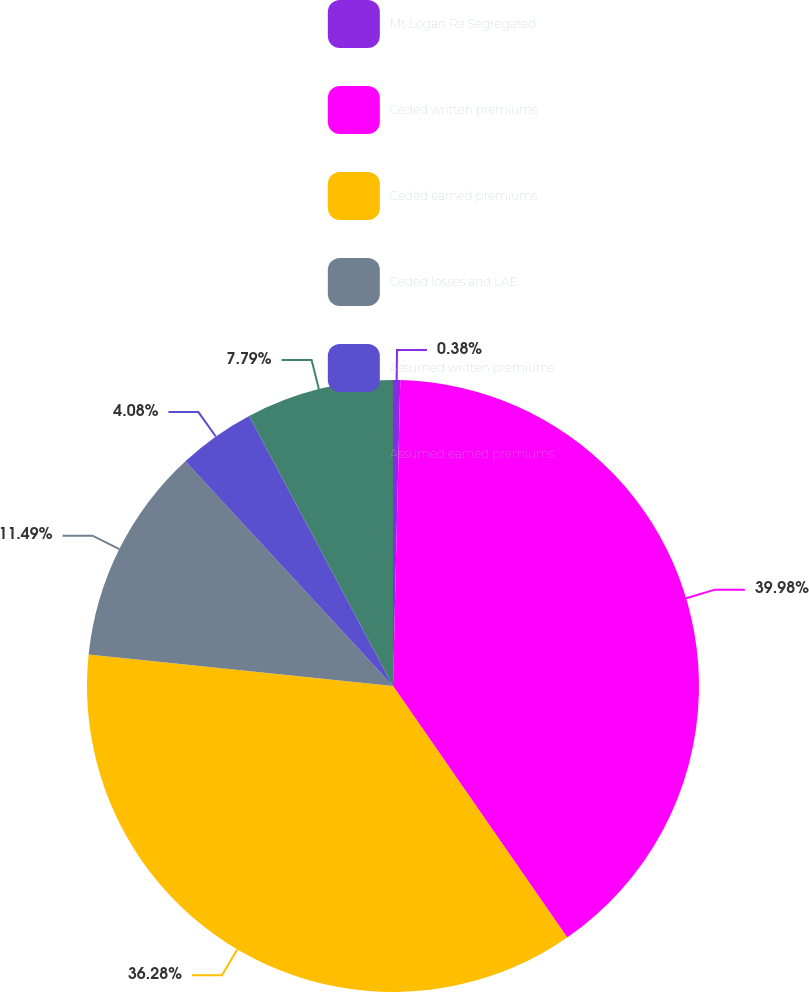<chart> <loc_0><loc_0><loc_500><loc_500><pie_chart><fcel>Mt Logan Re Segregated<fcel>Ceded written premiums<fcel>Ceded earned premiums<fcel>Ceded losses and LAE<fcel>Assumed written premiums<fcel>Assumed earned premiums<nl><fcel>0.38%<fcel>39.98%<fcel>36.28%<fcel>11.49%<fcel>4.08%<fcel>7.79%<nl></chart> 